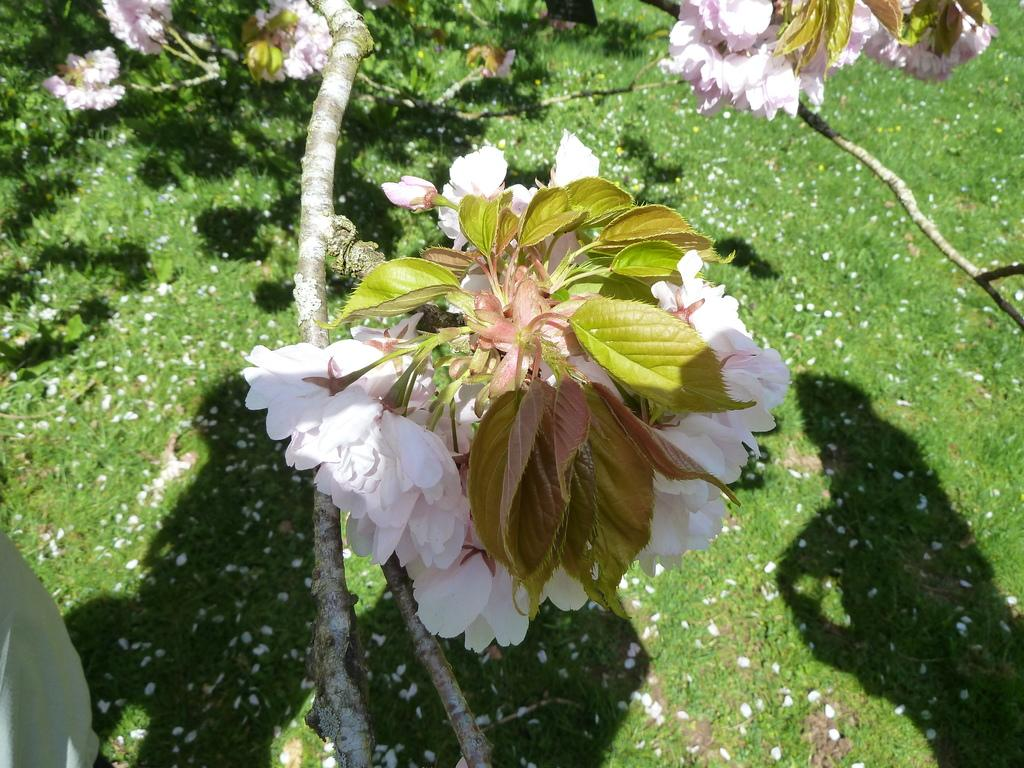What is on the tree in the image? There are flowers on the tree. What is on the ground beneath the tree? Flower petals are on the ground. What type of vegetation covers the ground? The ground is covered with grass. What scientific experiment is being conducted in the image? There is no scientific experiment visible in the image. What type of house can be seen in the background of the image? There is no house present in the image. 